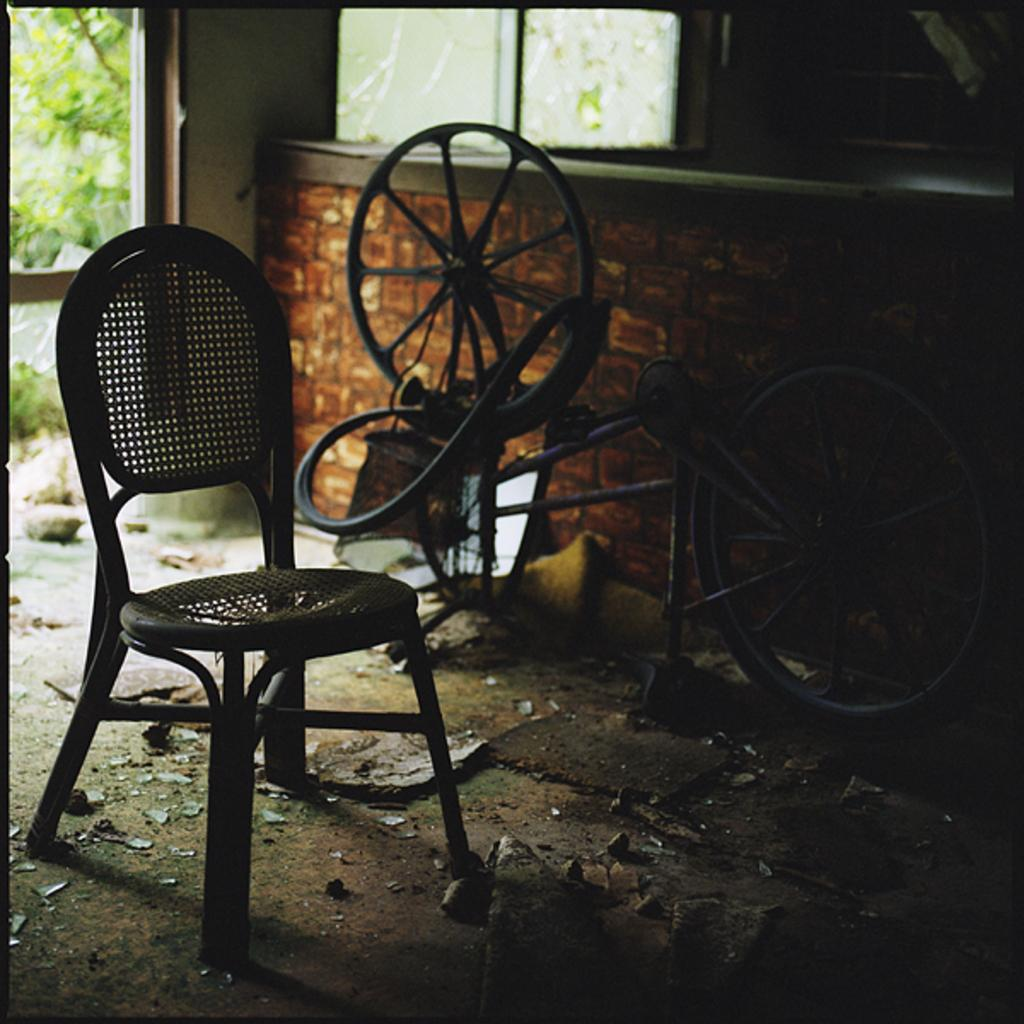What type of furniture is present in the image? There is a chair in the image. What mode of transportation is also visible in the image? There is a cycle in the image. Where are the chair and cycle located in the image? Both the chair and the cycle are on the ground. What type of throne is the ladybug sitting on in the image? There is no ladybug or throne present in the image. What time of day is depicted in the image? The provided facts do not mention the time of day, so it cannot be determined from the image. 